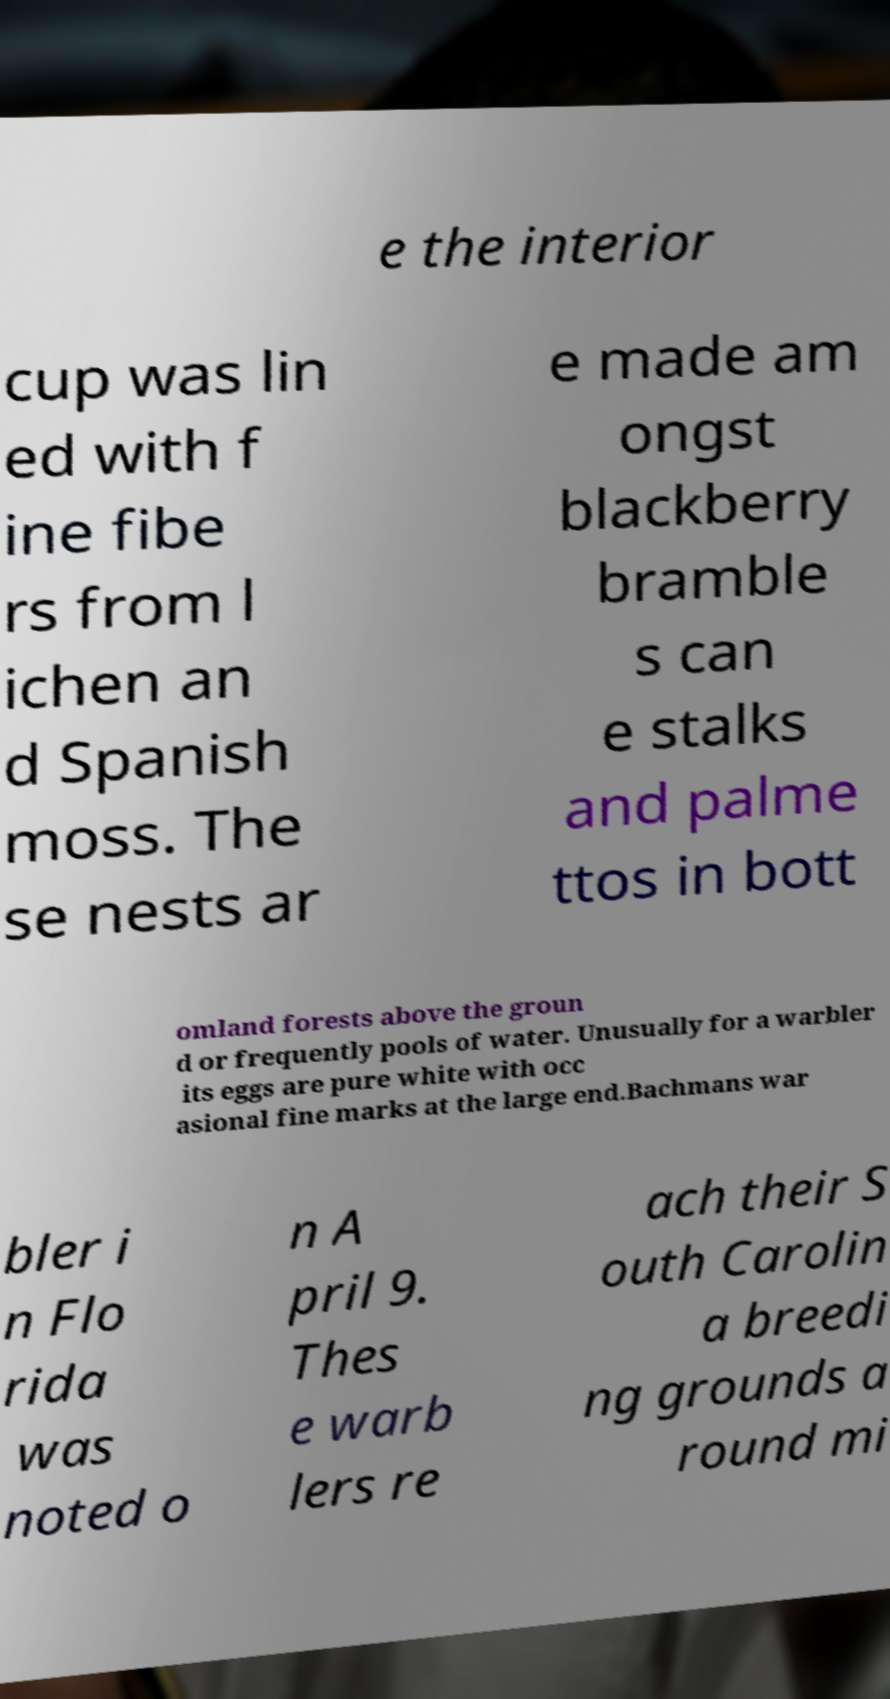Please identify and transcribe the text found in this image. e the interior cup was lin ed with f ine fibe rs from l ichen an d Spanish moss. The se nests ar e made am ongst blackberry bramble s can e stalks and palme ttos in bott omland forests above the groun d or frequently pools of water. Unusually for a warbler its eggs are pure white with occ asional fine marks at the large end.Bachmans war bler i n Flo rida was noted o n A pril 9. Thes e warb lers re ach their S outh Carolin a breedi ng grounds a round mi 